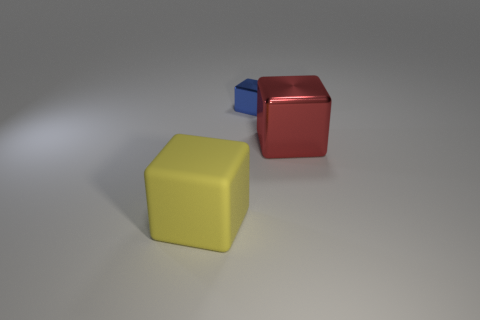Subtract all yellow cubes. How many cubes are left? 2 Add 1 big brown metallic cubes. How many objects exist? 4 Subtract all blue cubes. How many cubes are left? 2 Subtract 1 blocks. How many blocks are left? 2 Add 1 tiny blue things. How many tiny blue things exist? 2 Subtract 0 yellow cylinders. How many objects are left? 3 Subtract all gray blocks. Subtract all cyan spheres. How many blocks are left? 3 Subtract all cylinders. Subtract all red metallic cubes. How many objects are left? 2 Add 1 shiny things. How many shiny things are left? 3 